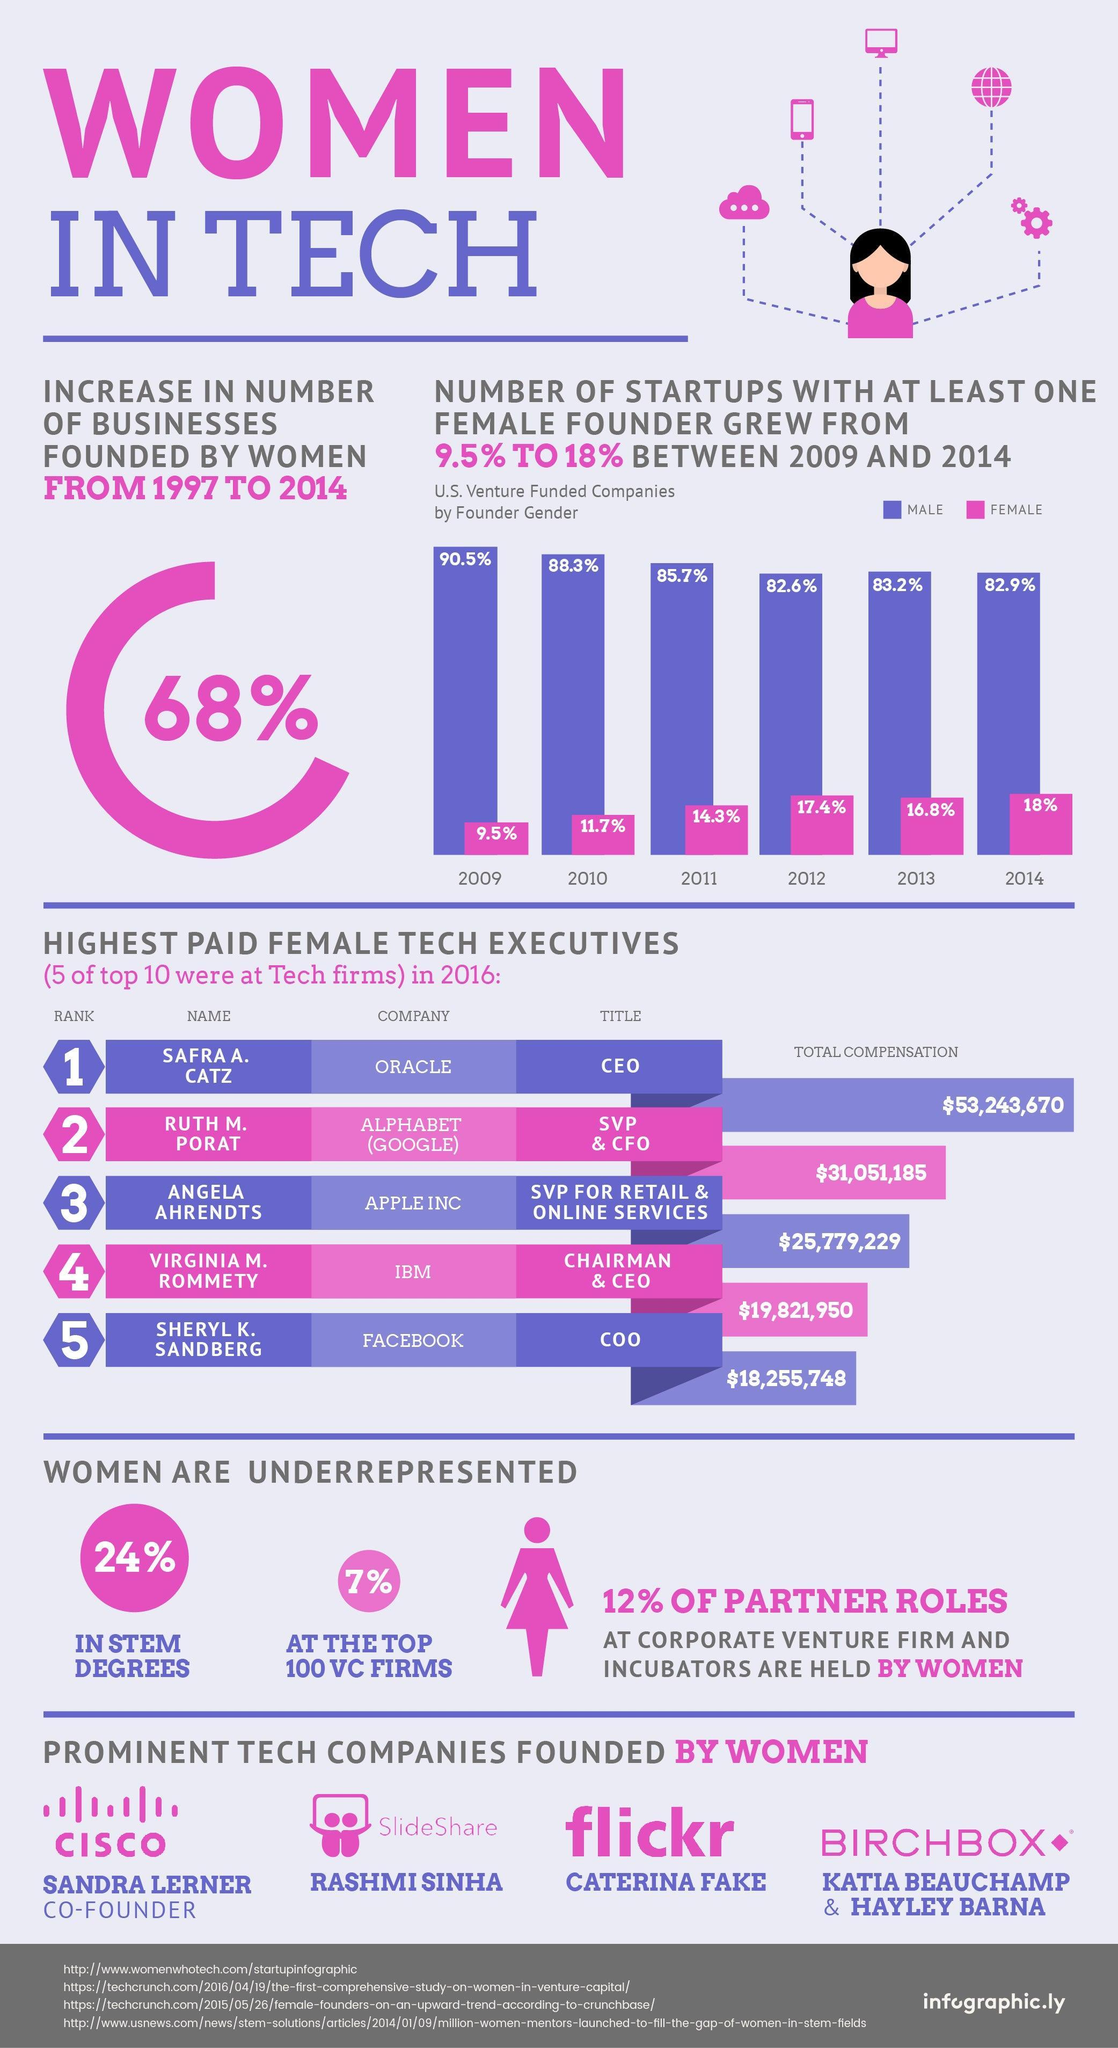What is the percentage drop in startups spearheaded by males 2013 to 2014 ?
Answer the question with a short phrase. 0.3% Who was the founder of Flickr, Sandra Lerner, Rashmi Sinha, or Caterina Fake? Caterina Fake 